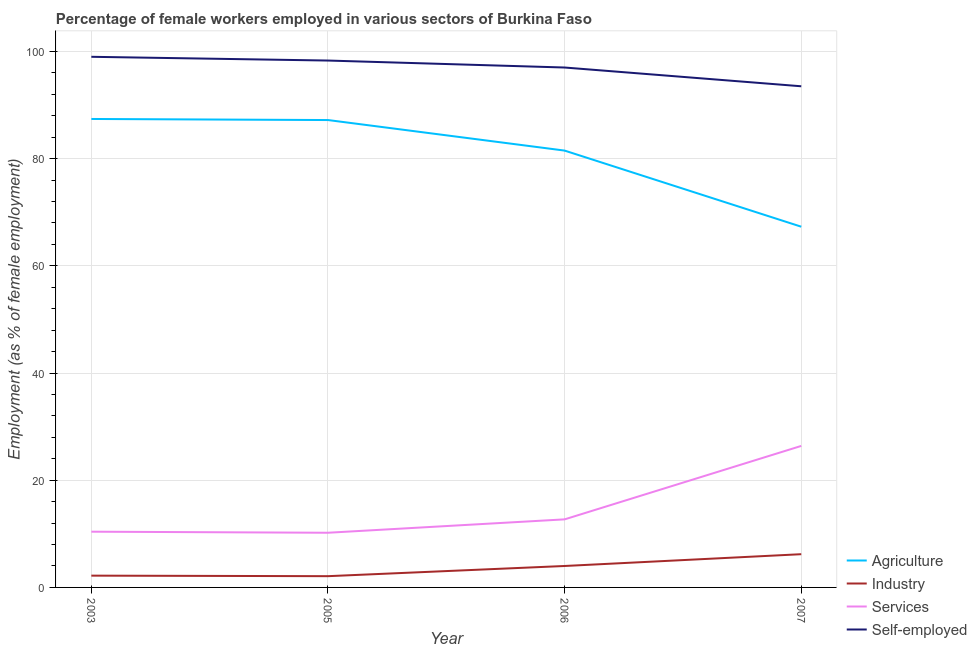How many different coloured lines are there?
Your answer should be compact. 4. Is the number of lines equal to the number of legend labels?
Keep it short and to the point. Yes. What is the percentage of female workers in industry in 2006?
Ensure brevity in your answer.  4. Across all years, what is the maximum percentage of female workers in agriculture?
Provide a succinct answer. 87.4. Across all years, what is the minimum percentage of female workers in services?
Your answer should be very brief. 10.2. In which year was the percentage of female workers in industry maximum?
Ensure brevity in your answer.  2007. What is the total percentage of female workers in industry in the graph?
Your response must be concise. 14.5. What is the difference between the percentage of self employed female workers in 2003 and that in 2007?
Your response must be concise. 5.5. What is the difference between the percentage of female workers in agriculture in 2006 and the percentage of female workers in industry in 2005?
Offer a terse response. 79.4. What is the average percentage of self employed female workers per year?
Ensure brevity in your answer.  96.95. In the year 2003, what is the difference between the percentage of self employed female workers and percentage of female workers in industry?
Offer a very short reply. 96.8. In how many years, is the percentage of self employed female workers greater than 88 %?
Ensure brevity in your answer.  4. What is the ratio of the percentage of female workers in services in 2005 to that in 2007?
Your answer should be very brief. 0.39. Is the percentage of female workers in agriculture in 2005 less than that in 2006?
Give a very brief answer. No. Is the difference between the percentage of female workers in industry in 2003 and 2005 greater than the difference between the percentage of female workers in agriculture in 2003 and 2005?
Make the answer very short. No. What is the difference between the highest and the second highest percentage of female workers in agriculture?
Make the answer very short. 0.2. What is the difference between the highest and the lowest percentage of female workers in industry?
Make the answer very short. 4.1. Is the sum of the percentage of self employed female workers in 2003 and 2005 greater than the maximum percentage of female workers in industry across all years?
Provide a succinct answer. Yes. Is it the case that in every year, the sum of the percentage of female workers in agriculture and percentage of female workers in industry is greater than the sum of percentage of female workers in services and percentage of self employed female workers?
Your answer should be very brief. No. Does the percentage of female workers in services monotonically increase over the years?
Provide a short and direct response. No. Is the percentage of female workers in services strictly less than the percentage of self employed female workers over the years?
Your answer should be compact. Yes. How many lines are there?
Your answer should be compact. 4. Does the graph contain grids?
Your answer should be very brief. Yes. How many legend labels are there?
Your answer should be very brief. 4. How are the legend labels stacked?
Your answer should be compact. Vertical. What is the title of the graph?
Offer a terse response. Percentage of female workers employed in various sectors of Burkina Faso. Does "Germany" appear as one of the legend labels in the graph?
Your answer should be compact. No. What is the label or title of the Y-axis?
Provide a short and direct response. Employment (as % of female employment). What is the Employment (as % of female employment) in Agriculture in 2003?
Your answer should be compact. 87.4. What is the Employment (as % of female employment) of Industry in 2003?
Offer a very short reply. 2.2. What is the Employment (as % of female employment) in Services in 2003?
Provide a short and direct response. 10.4. What is the Employment (as % of female employment) of Self-employed in 2003?
Offer a very short reply. 99. What is the Employment (as % of female employment) in Agriculture in 2005?
Ensure brevity in your answer.  87.2. What is the Employment (as % of female employment) of Industry in 2005?
Your answer should be compact. 2.1. What is the Employment (as % of female employment) of Services in 2005?
Offer a terse response. 10.2. What is the Employment (as % of female employment) of Self-employed in 2005?
Offer a terse response. 98.3. What is the Employment (as % of female employment) of Agriculture in 2006?
Make the answer very short. 81.5. What is the Employment (as % of female employment) of Industry in 2006?
Your response must be concise. 4. What is the Employment (as % of female employment) of Services in 2006?
Offer a terse response. 12.7. What is the Employment (as % of female employment) in Self-employed in 2006?
Ensure brevity in your answer.  97. What is the Employment (as % of female employment) in Agriculture in 2007?
Your answer should be compact. 67.3. What is the Employment (as % of female employment) of Industry in 2007?
Offer a terse response. 6.2. What is the Employment (as % of female employment) in Services in 2007?
Keep it short and to the point. 26.4. What is the Employment (as % of female employment) of Self-employed in 2007?
Provide a short and direct response. 93.5. Across all years, what is the maximum Employment (as % of female employment) of Agriculture?
Your response must be concise. 87.4. Across all years, what is the maximum Employment (as % of female employment) of Industry?
Provide a succinct answer. 6.2. Across all years, what is the maximum Employment (as % of female employment) in Services?
Offer a terse response. 26.4. Across all years, what is the maximum Employment (as % of female employment) in Self-employed?
Offer a terse response. 99. Across all years, what is the minimum Employment (as % of female employment) of Agriculture?
Your answer should be compact. 67.3. Across all years, what is the minimum Employment (as % of female employment) of Industry?
Offer a very short reply. 2.1. Across all years, what is the minimum Employment (as % of female employment) in Services?
Keep it short and to the point. 10.2. Across all years, what is the minimum Employment (as % of female employment) of Self-employed?
Give a very brief answer. 93.5. What is the total Employment (as % of female employment) in Agriculture in the graph?
Keep it short and to the point. 323.4. What is the total Employment (as % of female employment) of Services in the graph?
Your answer should be very brief. 59.7. What is the total Employment (as % of female employment) in Self-employed in the graph?
Your response must be concise. 387.8. What is the difference between the Employment (as % of female employment) of Industry in 2003 and that in 2005?
Make the answer very short. 0.1. What is the difference between the Employment (as % of female employment) in Services in 2003 and that in 2005?
Offer a terse response. 0.2. What is the difference between the Employment (as % of female employment) in Self-employed in 2003 and that in 2005?
Provide a short and direct response. 0.7. What is the difference between the Employment (as % of female employment) in Agriculture in 2003 and that in 2006?
Provide a succinct answer. 5.9. What is the difference between the Employment (as % of female employment) in Services in 2003 and that in 2006?
Make the answer very short. -2.3. What is the difference between the Employment (as % of female employment) of Self-employed in 2003 and that in 2006?
Your answer should be very brief. 2. What is the difference between the Employment (as % of female employment) in Agriculture in 2003 and that in 2007?
Provide a short and direct response. 20.1. What is the difference between the Employment (as % of female employment) in Industry in 2003 and that in 2007?
Give a very brief answer. -4. What is the difference between the Employment (as % of female employment) of Industry in 2005 and that in 2006?
Your answer should be very brief. -1.9. What is the difference between the Employment (as % of female employment) of Services in 2005 and that in 2006?
Provide a short and direct response. -2.5. What is the difference between the Employment (as % of female employment) of Self-employed in 2005 and that in 2006?
Keep it short and to the point. 1.3. What is the difference between the Employment (as % of female employment) in Agriculture in 2005 and that in 2007?
Keep it short and to the point. 19.9. What is the difference between the Employment (as % of female employment) in Services in 2005 and that in 2007?
Offer a terse response. -16.2. What is the difference between the Employment (as % of female employment) of Self-employed in 2005 and that in 2007?
Your response must be concise. 4.8. What is the difference between the Employment (as % of female employment) in Industry in 2006 and that in 2007?
Keep it short and to the point. -2.2. What is the difference between the Employment (as % of female employment) in Services in 2006 and that in 2007?
Your answer should be very brief. -13.7. What is the difference between the Employment (as % of female employment) of Agriculture in 2003 and the Employment (as % of female employment) of Industry in 2005?
Offer a very short reply. 85.3. What is the difference between the Employment (as % of female employment) of Agriculture in 2003 and the Employment (as % of female employment) of Services in 2005?
Provide a succinct answer. 77.2. What is the difference between the Employment (as % of female employment) of Agriculture in 2003 and the Employment (as % of female employment) of Self-employed in 2005?
Make the answer very short. -10.9. What is the difference between the Employment (as % of female employment) in Industry in 2003 and the Employment (as % of female employment) in Services in 2005?
Give a very brief answer. -8. What is the difference between the Employment (as % of female employment) in Industry in 2003 and the Employment (as % of female employment) in Self-employed in 2005?
Provide a short and direct response. -96.1. What is the difference between the Employment (as % of female employment) in Services in 2003 and the Employment (as % of female employment) in Self-employed in 2005?
Provide a succinct answer. -87.9. What is the difference between the Employment (as % of female employment) of Agriculture in 2003 and the Employment (as % of female employment) of Industry in 2006?
Provide a short and direct response. 83.4. What is the difference between the Employment (as % of female employment) in Agriculture in 2003 and the Employment (as % of female employment) in Services in 2006?
Make the answer very short. 74.7. What is the difference between the Employment (as % of female employment) of Agriculture in 2003 and the Employment (as % of female employment) of Self-employed in 2006?
Your response must be concise. -9.6. What is the difference between the Employment (as % of female employment) in Industry in 2003 and the Employment (as % of female employment) in Self-employed in 2006?
Ensure brevity in your answer.  -94.8. What is the difference between the Employment (as % of female employment) in Services in 2003 and the Employment (as % of female employment) in Self-employed in 2006?
Your answer should be very brief. -86.6. What is the difference between the Employment (as % of female employment) of Agriculture in 2003 and the Employment (as % of female employment) of Industry in 2007?
Provide a succinct answer. 81.2. What is the difference between the Employment (as % of female employment) in Agriculture in 2003 and the Employment (as % of female employment) in Services in 2007?
Your answer should be very brief. 61. What is the difference between the Employment (as % of female employment) in Agriculture in 2003 and the Employment (as % of female employment) in Self-employed in 2007?
Your answer should be compact. -6.1. What is the difference between the Employment (as % of female employment) of Industry in 2003 and the Employment (as % of female employment) of Services in 2007?
Keep it short and to the point. -24.2. What is the difference between the Employment (as % of female employment) in Industry in 2003 and the Employment (as % of female employment) in Self-employed in 2007?
Offer a very short reply. -91.3. What is the difference between the Employment (as % of female employment) in Services in 2003 and the Employment (as % of female employment) in Self-employed in 2007?
Keep it short and to the point. -83.1. What is the difference between the Employment (as % of female employment) in Agriculture in 2005 and the Employment (as % of female employment) in Industry in 2006?
Make the answer very short. 83.2. What is the difference between the Employment (as % of female employment) of Agriculture in 2005 and the Employment (as % of female employment) of Services in 2006?
Your answer should be very brief. 74.5. What is the difference between the Employment (as % of female employment) in Industry in 2005 and the Employment (as % of female employment) in Self-employed in 2006?
Provide a succinct answer. -94.9. What is the difference between the Employment (as % of female employment) of Services in 2005 and the Employment (as % of female employment) of Self-employed in 2006?
Offer a very short reply. -86.8. What is the difference between the Employment (as % of female employment) of Agriculture in 2005 and the Employment (as % of female employment) of Industry in 2007?
Provide a succinct answer. 81. What is the difference between the Employment (as % of female employment) in Agriculture in 2005 and the Employment (as % of female employment) in Services in 2007?
Your answer should be very brief. 60.8. What is the difference between the Employment (as % of female employment) of Agriculture in 2005 and the Employment (as % of female employment) of Self-employed in 2007?
Offer a very short reply. -6.3. What is the difference between the Employment (as % of female employment) in Industry in 2005 and the Employment (as % of female employment) in Services in 2007?
Offer a very short reply. -24.3. What is the difference between the Employment (as % of female employment) in Industry in 2005 and the Employment (as % of female employment) in Self-employed in 2007?
Your response must be concise. -91.4. What is the difference between the Employment (as % of female employment) of Services in 2005 and the Employment (as % of female employment) of Self-employed in 2007?
Make the answer very short. -83.3. What is the difference between the Employment (as % of female employment) of Agriculture in 2006 and the Employment (as % of female employment) of Industry in 2007?
Ensure brevity in your answer.  75.3. What is the difference between the Employment (as % of female employment) in Agriculture in 2006 and the Employment (as % of female employment) in Services in 2007?
Make the answer very short. 55.1. What is the difference between the Employment (as % of female employment) of Agriculture in 2006 and the Employment (as % of female employment) of Self-employed in 2007?
Your answer should be very brief. -12. What is the difference between the Employment (as % of female employment) of Industry in 2006 and the Employment (as % of female employment) of Services in 2007?
Give a very brief answer. -22.4. What is the difference between the Employment (as % of female employment) of Industry in 2006 and the Employment (as % of female employment) of Self-employed in 2007?
Make the answer very short. -89.5. What is the difference between the Employment (as % of female employment) of Services in 2006 and the Employment (as % of female employment) of Self-employed in 2007?
Your response must be concise. -80.8. What is the average Employment (as % of female employment) in Agriculture per year?
Your answer should be compact. 80.85. What is the average Employment (as % of female employment) in Industry per year?
Provide a short and direct response. 3.62. What is the average Employment (as % of female employment) in Services per year?
Your answer should be very brief. 14.93. What is the average Employment (as % of female employment) of Self-employed per year?
Your answer should be very brief. 96.95. In the year 2003, what is the difference between the Employment (as % of female employment) of Agriculture and Employment (as % of female employment) of Industry?
Your answer should be compact. 85.2. In the year 2003, what is the difference between the Employment (as % of female employment) in Agriculture and Employment (as % of female employment) in Self-employed?
Give a very brief answer. -11.6. In the year 2003, what is the difference between the Employment (as % of female employment) in Industry and Employment (as % of female employment) in Services?
Your answer should be very brief. -8.2. In the year 2003, what is the difference between the Employment (as % of female employment) of Industry and Employment (as % of female employment) of Self-employed?
Give a very brief answer. -96.8. In the year 2003, what is the difference between the Employment (as % of female employment) in Services and Employment (as % of female employment) in Self-employed?
Your answer should be very brief. -88.6. In the year 2005, what is the difference between the Employment (as % of female employment) in Agriculture and Employment (as % of female employment) in Industry?
Offer a very short reply. 85.1. In the year 2005, what is the difference between the Employment (as % of female employment) in Agriculture and Employment (as % of female employment) in Services?
Ensure brevity in your answer.  77. In the year 2005, what is the difference between the Employment (as % of female employment) of Agriculture and Employment (as % of female employment) of Self-employed?
Your response must be concise. -11.1. In the year 2005, what is the difference between the Employment (as % of female employment) of Industry and Employment (as % of female employment) of Services?
Keep it short and to the point. -8.1. In the year 2005, what is the difference between the Employment (as % of female employment) of Industry and Employment (as % of female employment) of Self-employed?
Your response must be concise. -96.2. In the year 2005, what is the difference between the Employment (as % of female employment) in Services and Employment (as % of female employment) in Self-employed?
Provide a short and direct response. -88.1. In the year 2006, what is the difference between the Employment (as % of female employment) of Agriculture and Employment (as % of female employment) of Industry?
Make the answer very short. 77.5. In the year 2006, what is the difference between the Employment (as % of female employment) in Agriculture and Employment (as % of female employment) in Services?
Your answer should be compact. 68.8. In the year 2006, what is the difference between the Employment (as % of female employment) in Agriculture and Employment (as % of female employment) in Self-employed?
Your response must be concise. -15.5. In the year 2006, what is the difference between the Employment (as % of female employment) in Industry and Employment (as % of female employment) in Services?
Give a very brief answer. -8.7. In the year 2006, what is the difference between the Employment (as % of female employment) in Industry and Employment (as % of female employment) in Self-employed?
Make the answer very short. -93. In the year 2006, what is the difference between the Employment (as % of female employment) of Services and Employment (as % of female employment) of Self-employed?
Offer a very short reply. -84.3. In the year 2007, what is the difference between the Employment (as % of female employment) of Agriculture and Employment (as % of female employment) of Industry?
Your answer should be compact. 61.1. In the year 2007, what is the difference between the Employment (as % of female employment) of Agriculture and Employment (as % of female employment) of Services?
Keep it short and to the point. 40.9. In the year 2007, what is the difference between the Employment (as % of female employment) of Agriculture and Employment (as % of female employment) of Self-employed?
Your response must be concise. -26.2. In the year 2007, what is the difference between the Employment (as % of female employment) in Industry and Employment (as % of female employment) in Services?
Keep it short and to the point. -20.2. In the year 2007, what is the difference between the Employment (as % of female employment) of Industry and Employment (as % of female employment) of Self-employed?
Your response must be concise. -87.3. In the year 2007, what is the difference between the Employment (as % of female employment) in Services and Employment (as % of female employment) in Self-employed?
Keep it short and to the point. -67.1. What is the ratio of the Employment (as % of female employment) in Agriculture in 2003 to that in 2005?
Provide a short and direct response. 1. What is the ratio of the Employment (as % of female employment) of Industry in 2003 to that in 2005?
Ensure brevity in your answer.  1.05. What is the ratio of the Employment (as % of female employment) of Services in 2003 to that in 2005?
Make the answer very short. 1.02. What is the ratio of the Employment (as % of female employment) in Self-employed in 2003 to that in 2005?
Your answer should be compact. 1.01. What is the ratio of the Employment (as % of female employment) of Agriculture in 2003 to that in 2006?
Offer a very short reply. 1.07. What is the ratio of the Employment (as % of female employment) of Industry in 2003 to that in 2006?
Offer a very short reply. 0.55. What is the ratio of the Employment (as % of female employment) in Services in 2003 to that in 2006?
Offer a terse response. 0.82. What is the ratio of the Employment (as % of female employment) of Self-employed in 2003 to that in 2006?
Give a very brief answer. 1.02. What is the ratio of the Employment (as % of female employment) of Agriculture in 2003 to that in 2007?
Ensure brevity in your answer.  1.3. What is the ratio of the Employment (as % of female employment) in Industry in 2003 to that in 2007?
Offer a very short reply. 0.35. What is the ratio of the Employment (as % of female employment) of Services in 2003 to that in 2007?
Ensure brevity in your answer.  0.39. What is the ratio of the Employment (as % of female employment) in Self-employed in 2003 to that in 2007?
Give a very brief answer. 1.06. What is the ratio of the Employment (as % of female employment) of Agriculture in 2005 to that in 2006?
Ensure brevity in your answer.  1.07. What is the ratio of the Employment (as % of female employment) of Industry in 2005 to that in 2006?
Your answer should be compact. 0.53. What is the ratio of the Employment (as % of female employment) in Services in 2005 to that in 2006?
Keep it short and to the point. 0.8. What is the ratio of the Employment (as % of female employment) in Self-employed in 2005 to that in 2006?
Make the answer very short. 1.01. What is the ratio of the Employment (as % of female employment) of Agriculture in 2005 to that in 2007?
Provide a succinct answer. 1.3. What is the ratio of the Employment (as % of female employment) of Industry in 2005 to that in 2007?
Provide a succinct answer. 0.34. What is the ratio of the Employment (as % of female employment) in Services in 2005 to that in 2007?
Your answer should be very brief. 0.39. What is the ratio of the Employment (as % of female employment) in Self-employed in 2005 to that in 2007?
Your answer should be very brief. 1.05. What is the ratio of the Employment (as % of female employment) of Agriculture in 2006 to that in 2007?
Ensure brevity in your answer.  1.21. What is the ratio of the Employment (as % of female employment) in Industry in 2006 to that in 2007?
Provide a succinct answer. 0.65. What is the ratio of the Employment (as % of female employment) in Services in 2006 to that in 2007?
Give a very brief answer. 0.48. What is the ratio of the Employment (as % of female employment) of Self-employed in 2006 to that in 2007?
Ensure brevity in your answer.  1.04. What is the difference between the highest and the second highest Employment (as % of female employment) of Agriculture?
Provide a short and direct response. 0.2. What is the difference between the highest and the second highest Employment (as % of female employment) of Industry?
Provide a succinct answer. 2.2. What is the difference between the highest and the second highest Employment (as % of female employment) in Services?
Give a very brief answer. 13.7. What is the difference between the highest and the second highest Employment (as % of female employment) in Self-employed?
Give a very brief answer. 0.7. What is the difference between the highest and the lowest Employment (as % of female employment) of Agriculture?
Provide a succinct answer. 20.1. What is the difference between the highest and the lowest Employment (as % of female employment) in Industry?
Make the answer very short. 4.1. What is the difference between the highest and the lowest Employment (as % of female employment) in Services?
Provide a short and direct response. 16.2. 